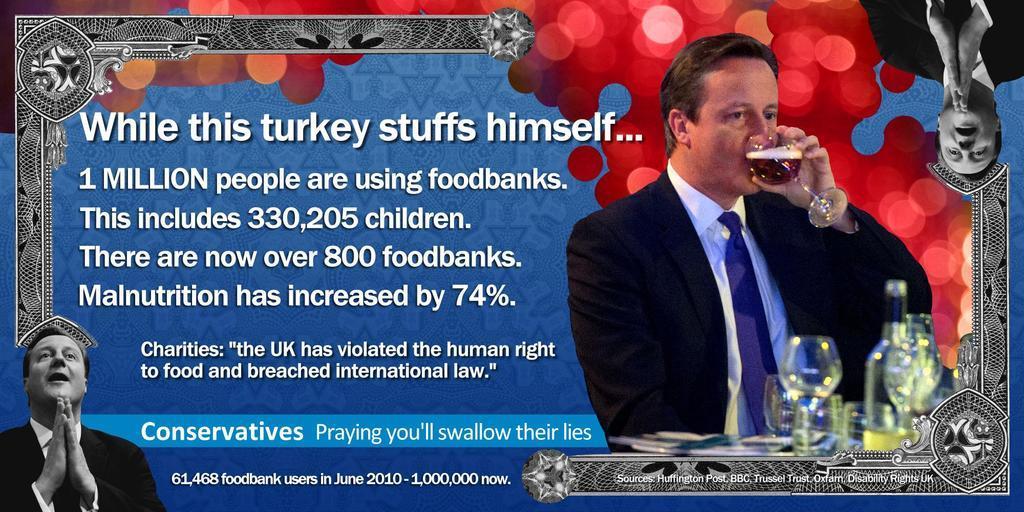Could you give a brief overview of what you see in this image? In the picture I can see the banner which is in blue and red color in which I can see the images of a person wearing black color blazer and here I can see glasses kept on the surface and this person is holding a glass with a drink in it. On the left side of the image I can see some edited text. 